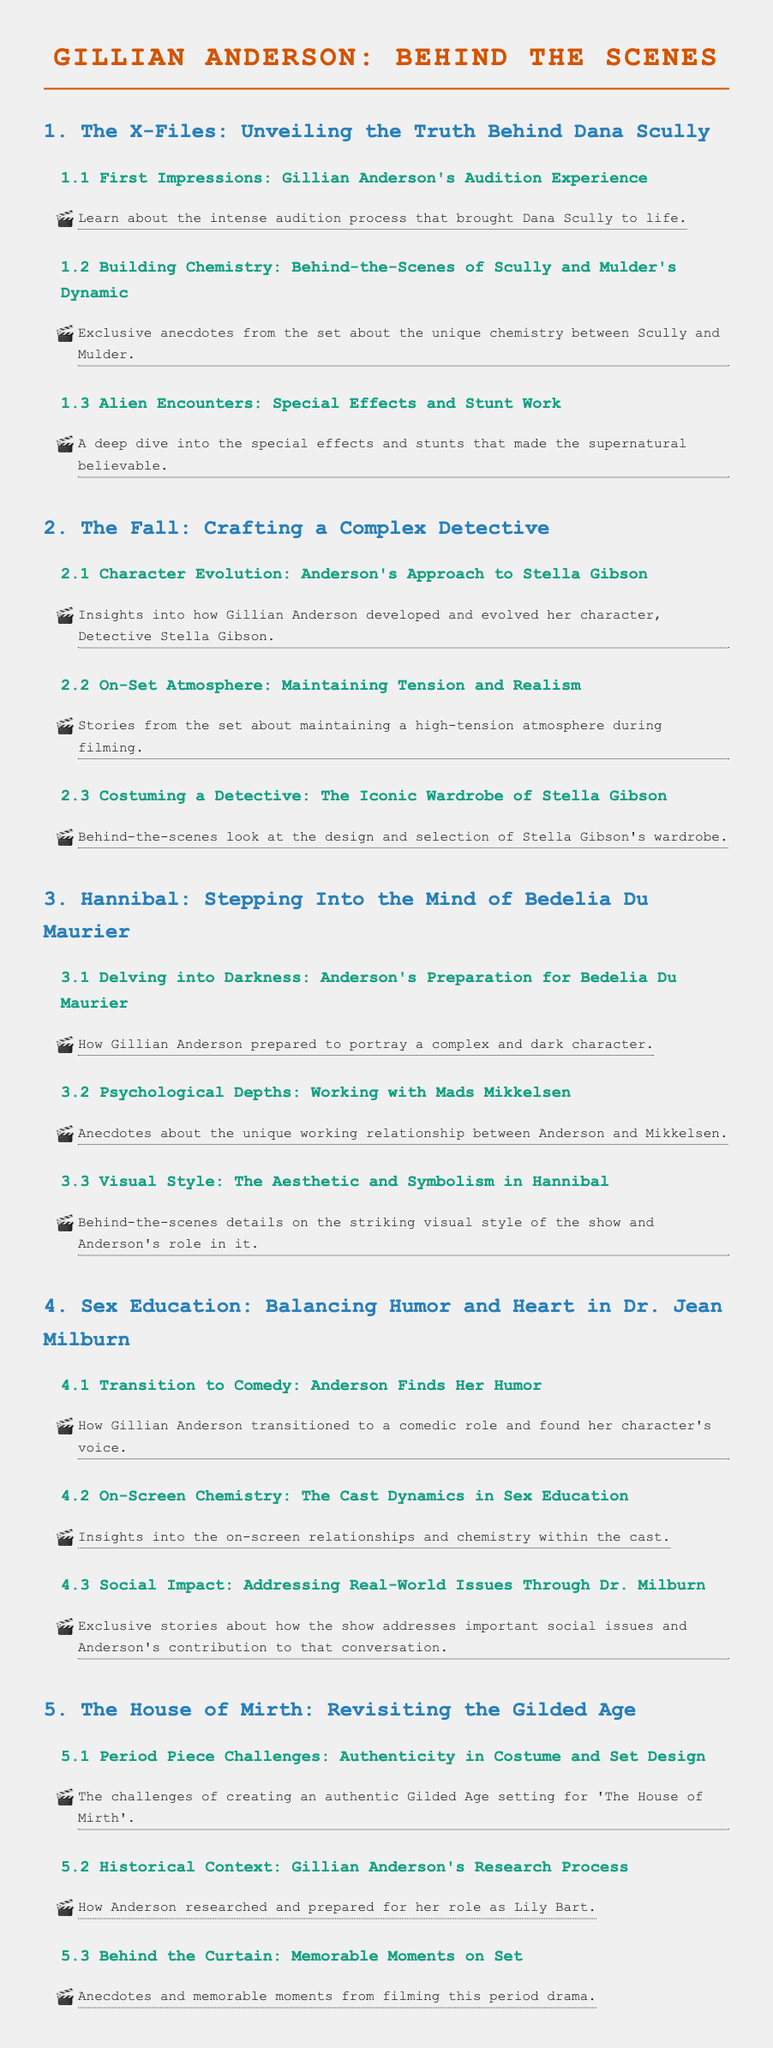What is the title of the document? The title of the document is presented prominently at the top.
Answer: Gillian Anderson: Behind the Scenes How many main sections are there in the document? The document has sections numbered from 1 to 5, indicating the number of main sections.
Answer: 5 What character does Gillian Anderson portray in The Fall? The character name is provided under the relevant section in the document.
Answer: Stella Gibson What is the focus of section 4? The title of the section summarizes the theme explored in that part of the document.
Answer: Balancing Humor and Heart in Dr. Jean Milburn Which project is associated with the phrase "Corsets and candelabras"? The phrase describes a specific project mentioned in the period piece challenges subsection.
Answer: The House of Mirth What type of anecdotes are included in section 3 about Hannibal? The section title gives insight into the nature of the anecdotes shared in this part.
Answer: Unique working relationship What is the tooltip about the first impressions of Gillian Anderson's audition? The tooltip provides an interesting detail about the nature of the audition experience.
Answer: It involved a lot of skeptical eyebrow raising! How does the document describe Stella Gibson's wardrobe? The description highlights a key aspect of the character's appearance in the show.
Answer: The secret to power dressing? Silk. Lots of silk How does Gillian Anderson prepare for her role as Bedelia Du Maurier? The preparation steps are summarized succinctly in the tooltip of that section.
Answer: Step 1: Watch 'Silence of the Lambs'. Step 2: Don't get eaten 